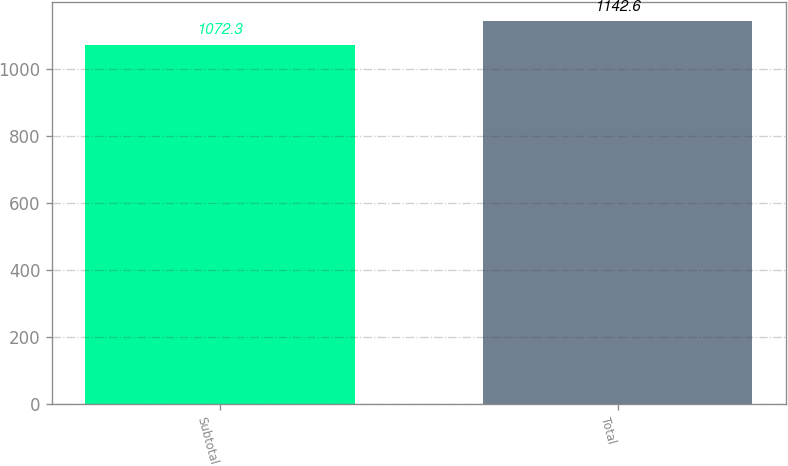Convert chart. <chart><loc_0><loc_0><loc_500><loc_500><bar_chart><fcel>Subtotal<fcel>Total<nl><fcel>1072.3<fcel>1142.6<nl></chart> 